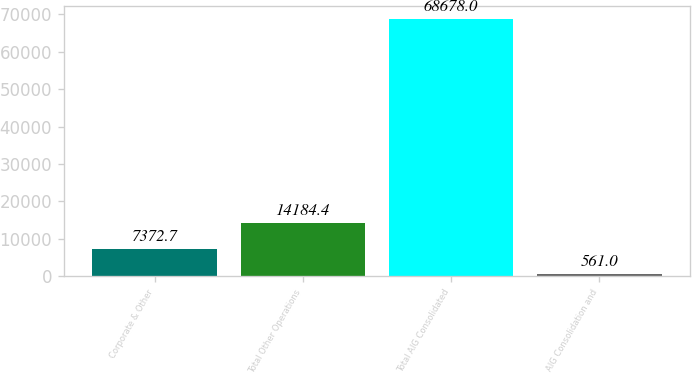Convert chart to OTSL. <chart><loc_0><loc_0><loc_500><loc_500><bar_chart><fcel>Corporate & Other<fcel>Total Other Operations<fcel>Total AIG Consolidated<fcel>AIG Consolidation and<nl><fcel>7372.7<fcel>14184.4<fcel>68678<fcel>561<nl></chart> 